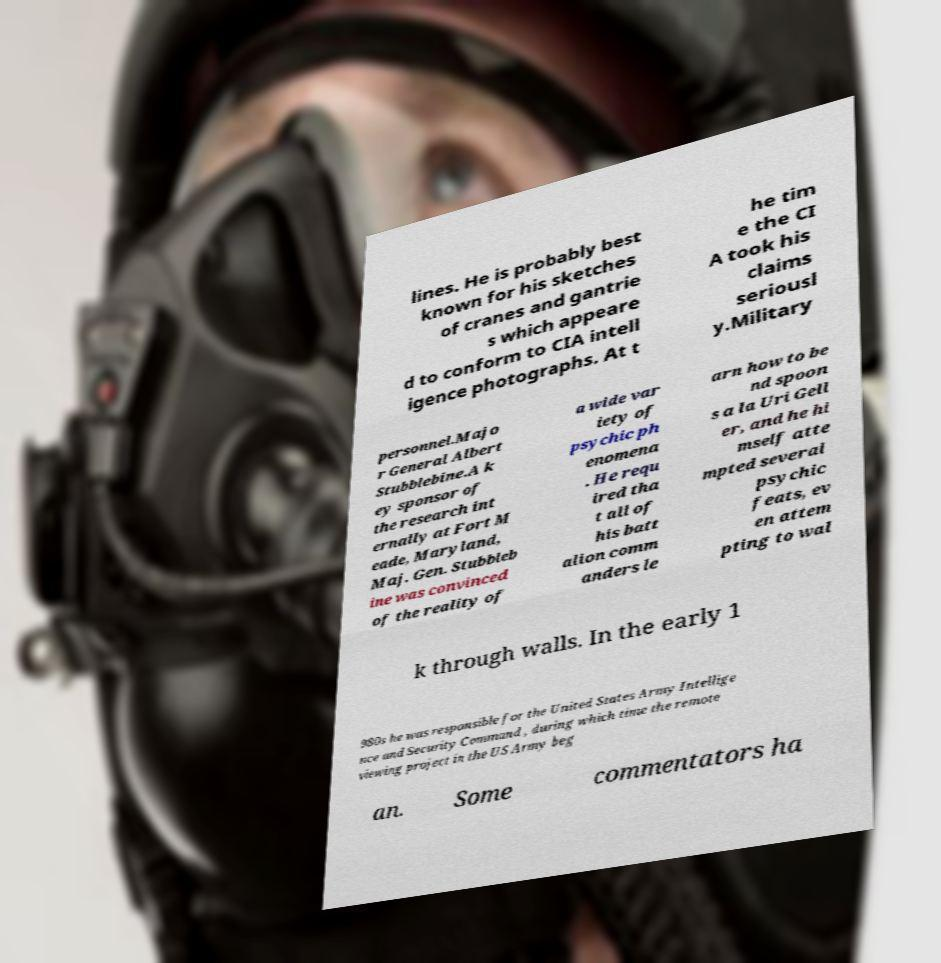Can you accurately transcribe the text from the provided image for me? lines. He is probably best known for his sketches of cranes and gantrie s which appeare d to conform to CIA intell igence photographs. At t he tim e the CI A took his claims seriousl y.Military personnel.Majo r General Albert Stubblebine.A k ey sponsor of the research int ernally at Fort M eade, Maryland, Maj. Gen. Stubbleb ine was convinced of the reality of a wide var iety of psychic ph enomena . He requ ired tha t all of his batt alion comm anders le arn how to be nd spoon s a la Uri Gell er, and he hi mself atte mpted several psychic feats, ev en attem pting to wal k through walls. In the early 1 980s he was responsible for the United States Army Intellige nce and Security Command , during which time the remote viewing project in the US Army beg an. Some commentators ha 